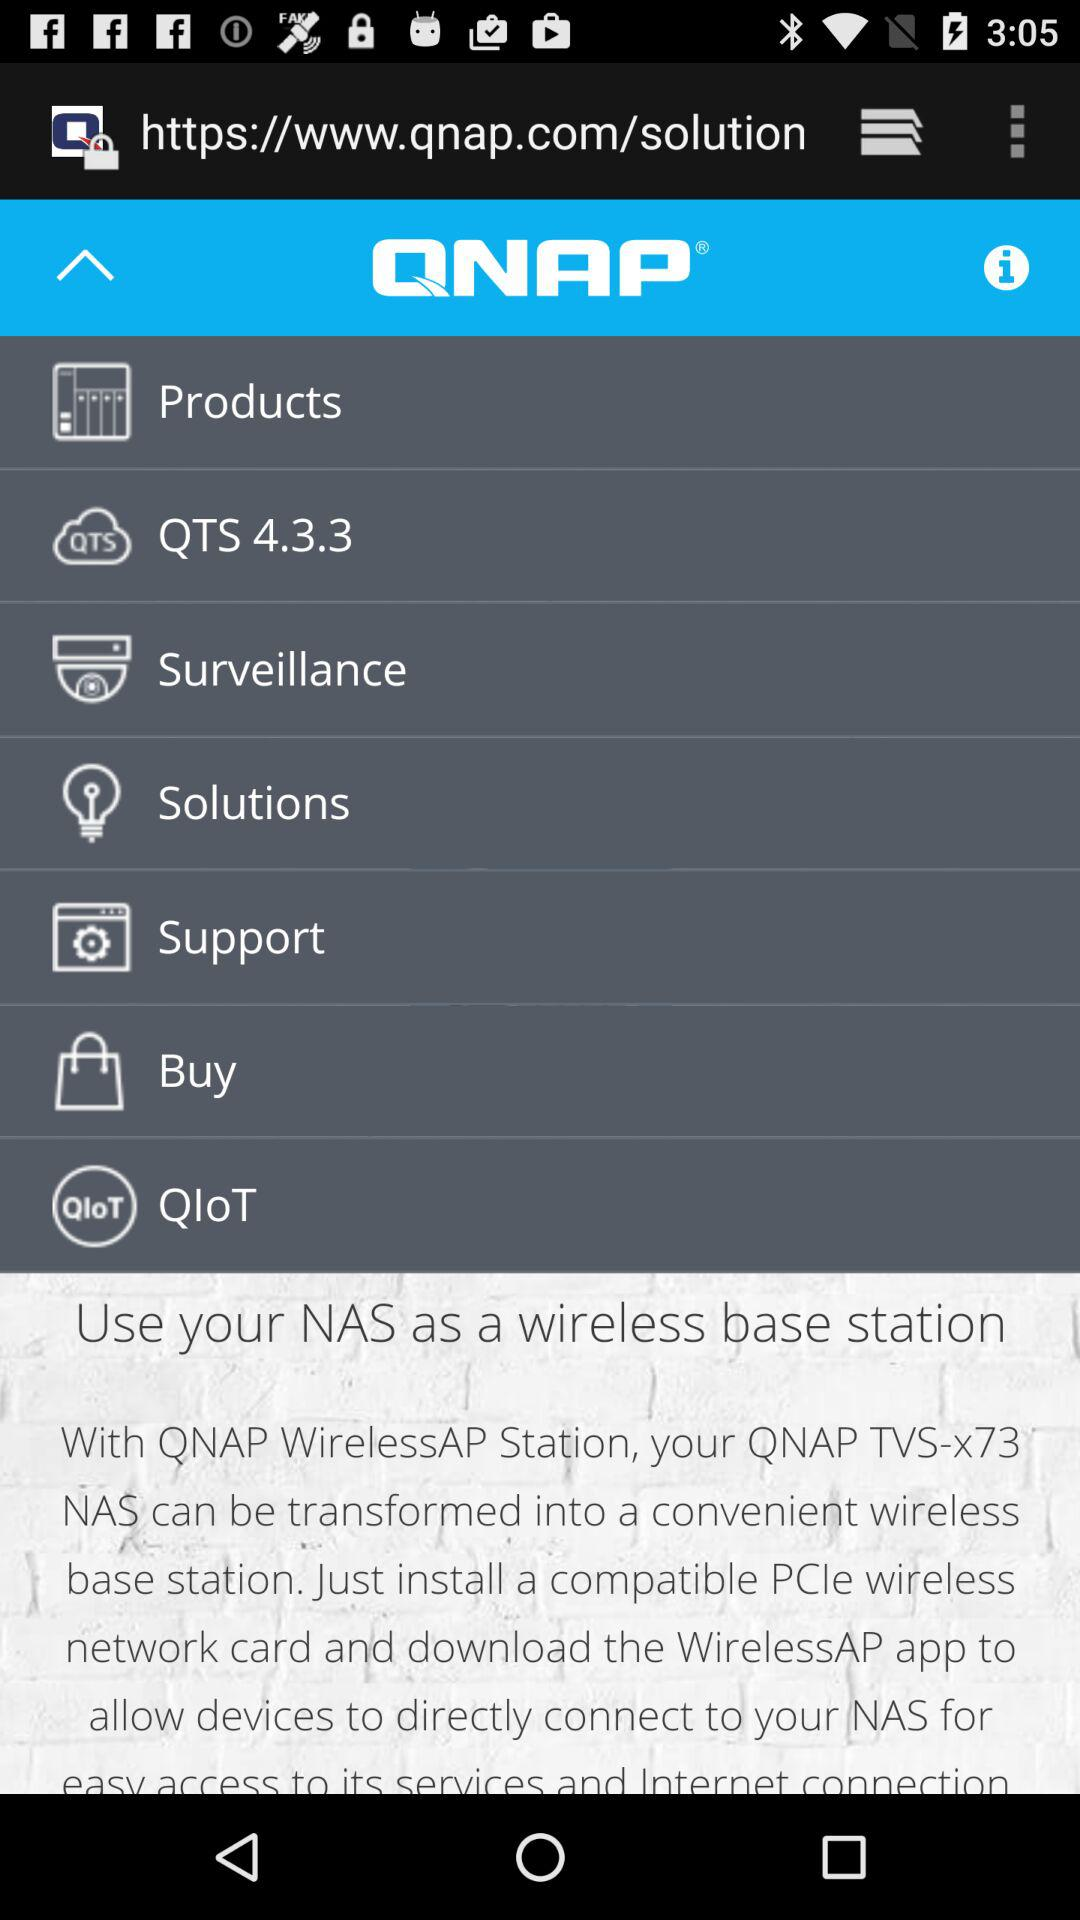What is the name of the application? The name of the application is "QNAP". 